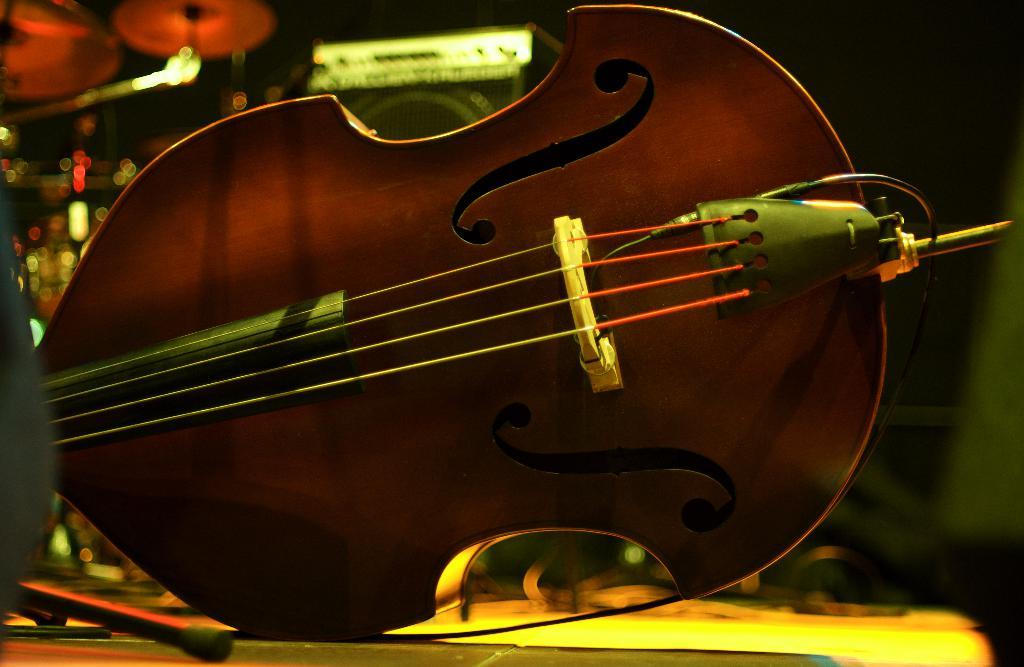What is the main object in the image? There is a guitar in the image. Where is the guitar located? The guitar is placed on a table. What feature of the guitar is mentioned in the facts? The guitar has strings. What else can be seen in the background of the image? There are musical instruments and lights visible in the background. How does the guitar react to the earthquake in the image? There is no earthquake present in the image, so the guitar's reaction cannot be determined. 